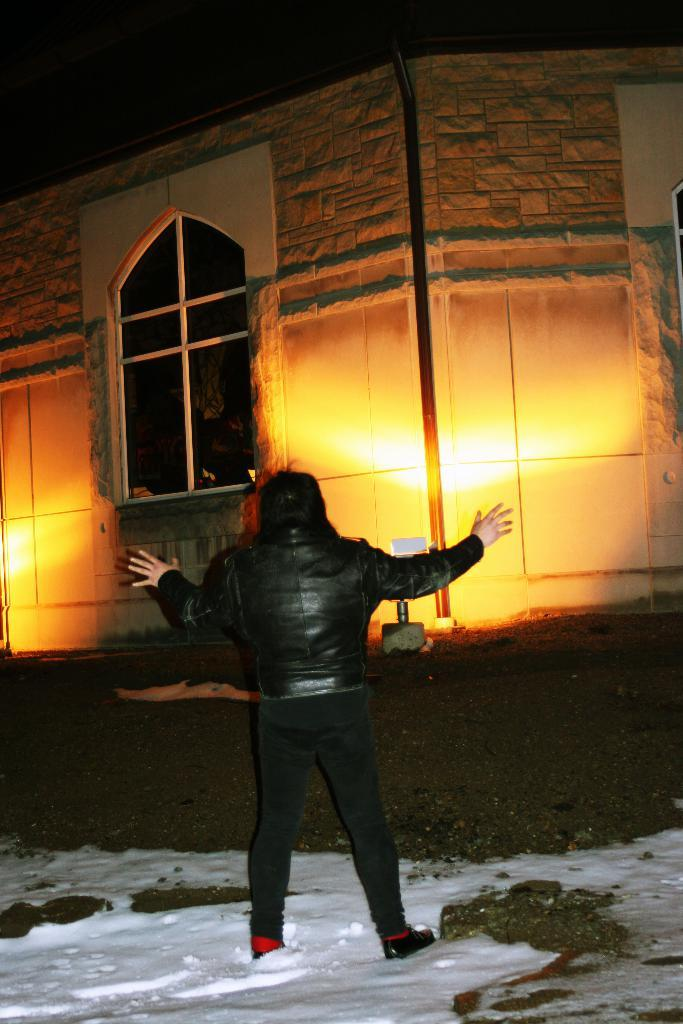What is the main subject of the image? There is a person in the image. What is the person wearing? The person is wearing a black jacket. What type of terrain is the person standing on? The person is standing on snow. What is in front of the person? There is a building in front of the person. What feature can be seen on the building? The building has a light ray on it. What type of desk can be seen in the image? There is no desk present in the image. How many feet does the person have in the image? The image does not show the person's feet, so it cannot be determined how many feet they have. 